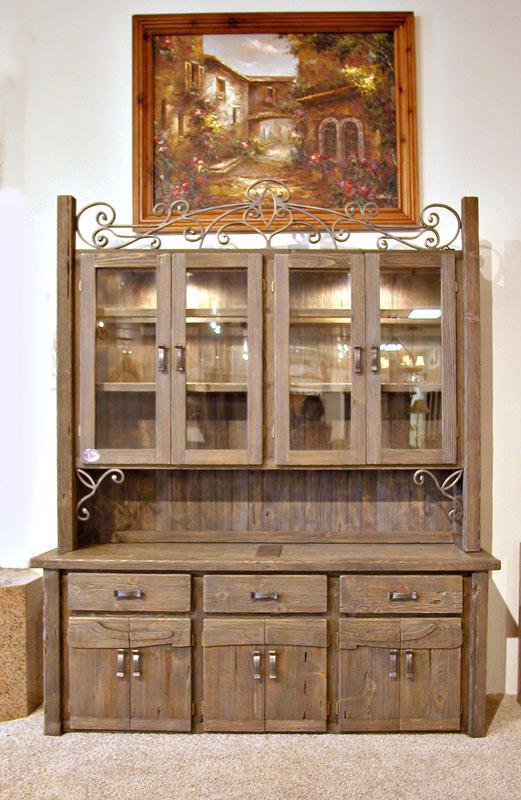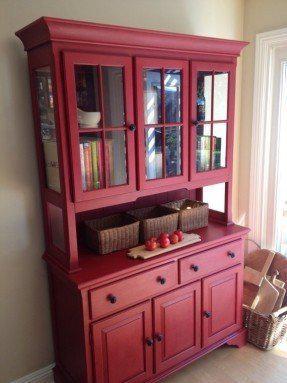The first image is the image on the left, the second image is the image on the right. Examine the images to the left and right. Is the description "An image shows a cabinet with a non-flat top and with feet." accurate? Answer yes or no. No. The first image is the image on the left, the second image is the image on the right. Examine the images to the left and right. Is the description "In one image, a wooden hutch sits on short legs and has three doors at the top, three at the bottom, and two drawers in the middle." accurate? Answer yes or no. Yes. 